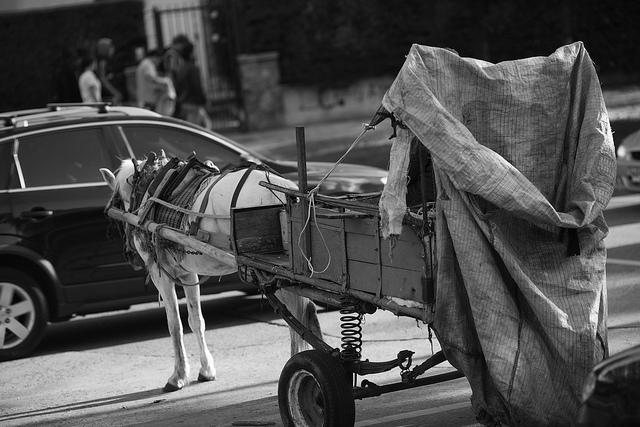Why is the animal that is hooked up to the cart doing? Please explain your reasoning. waiting. The animal--a horse--hooked up to the cart is just standing there patiently, not doing anything, and his idle nature suggests that he is just waiting for something and/or someone. 